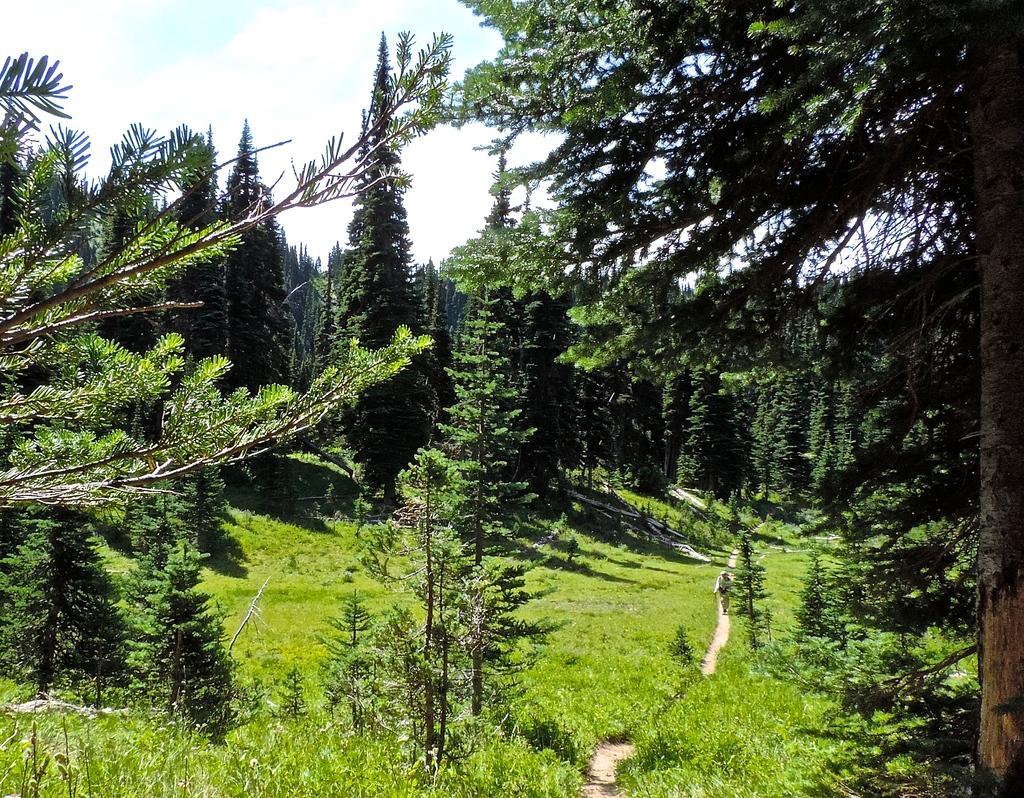Please provide a concise description of this image. This is an outside view. On the ground, I can see the grass. In the background there are many trees. On the right side there is a person walking. At the top of the image, I can see the sky. 